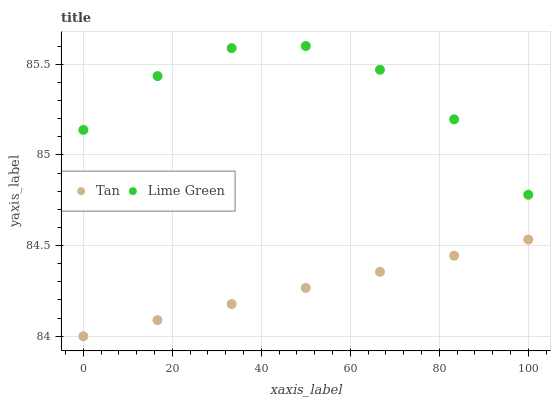Does Tan have the minimum area under the curve?
Answer yes or no. Yes. Does Lime Green have the maximum area under the curve?
Answer yes or no. Yes. Does Lime Green have the minimum area under the curve?
Answer yes or no. No. Is Tan the smoothest?
Answer yes or no. Yes. Is Lime Green the roughest?
Answer yes or no. Yes. Is Lime Green the smoothest?
Answer yes or no. No. Does Tan have the lowest value?
Answer yes or no. Yes. Does Lime Green have the lowest value?
Answer yes or no. No. Does Lime Green have the highest value?
Answer yes or no. Yes. Is Tan less than Lime Green?
Answer yes or no. Yes. Is Lime Green greater than Tan?
Answer yes or no. Yes. Does Tan intersect Lime Green?
Answer yes or no. No. 